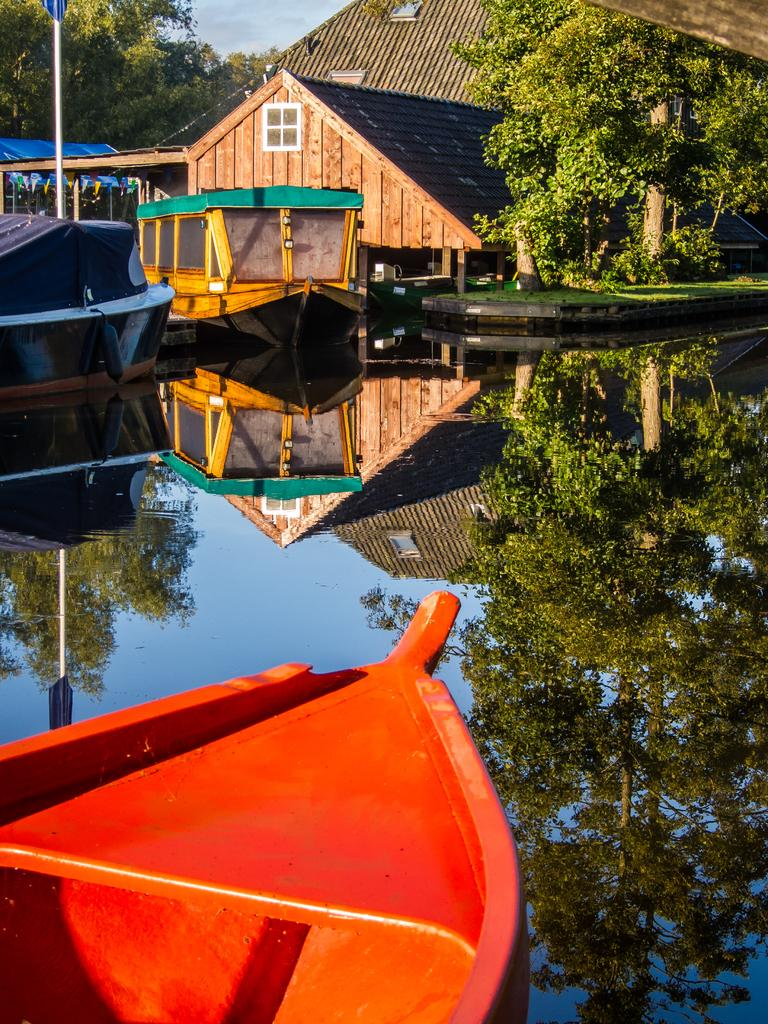What is on the water in the image? There are boats on the water in the image. What structures can be seen in the image? There are buildings visible in the image. What objects are present in the image besides the boats and buildings? There are poles and trees in the image. What can be seen above the water and structures in the image? The sky is visible in the image, and clouds are present in the sky. Can you tell me how many horses are visible in the image? There are no horses present in the image. What type of van can be seen parked near the water in the image? There is no van present in the image. 